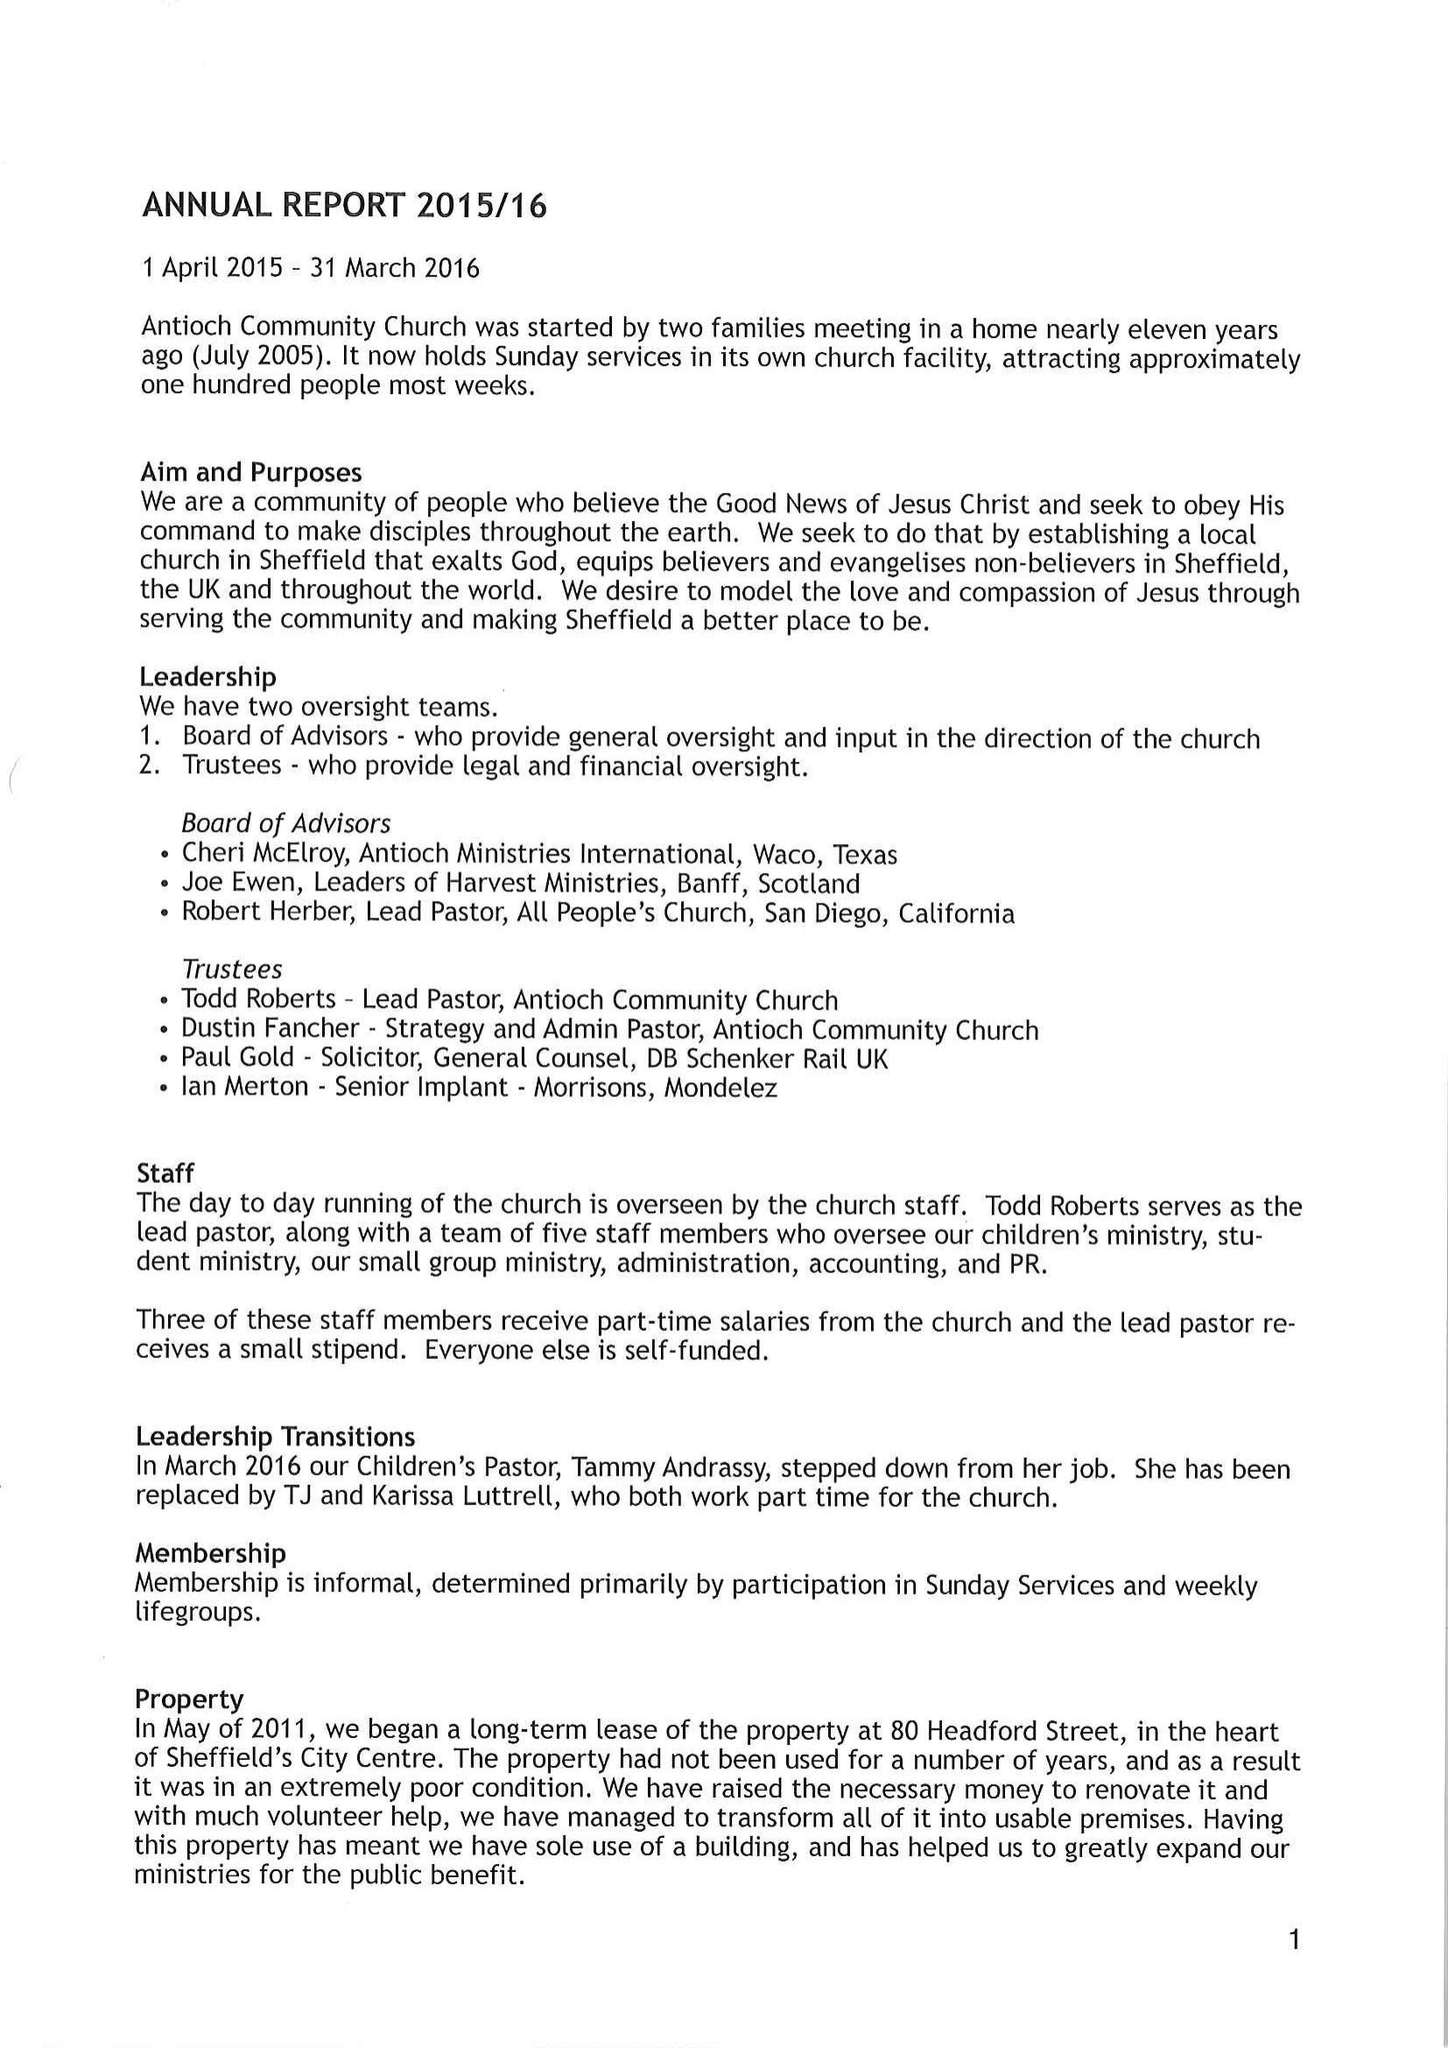What is the value for the charity_name?
Answer the question using a single word or phrase. Antioch Community Church 